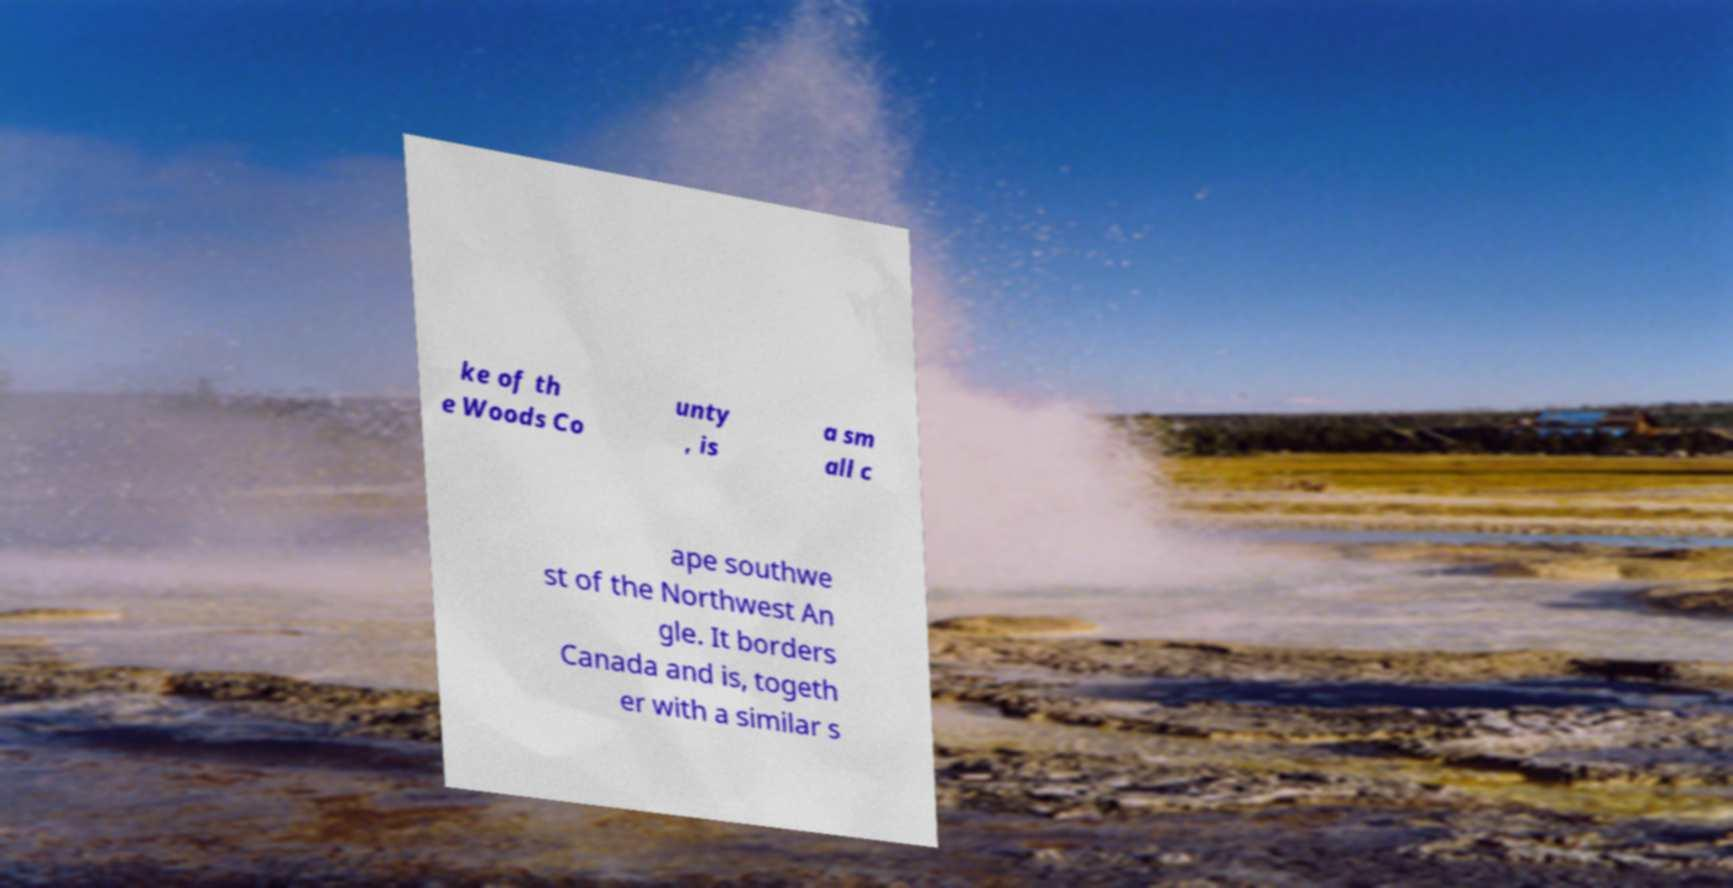Can you read and provide the text displayed in the image?This photo seems to have some interesting text. Can you extract and type it out for me? ke of th e Woods Co unty , is a sm all c ape southwe st of the Northwest An gle. It borders Canada and is, togeth er with a similar s 